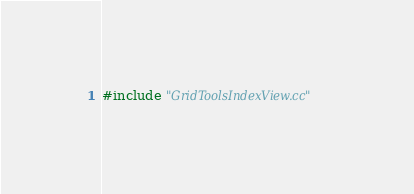<code> <loc_0><loc_0><loc_500><loc_500><_Cuda_>#include "GridToolsIndexView.cc"
</code> 